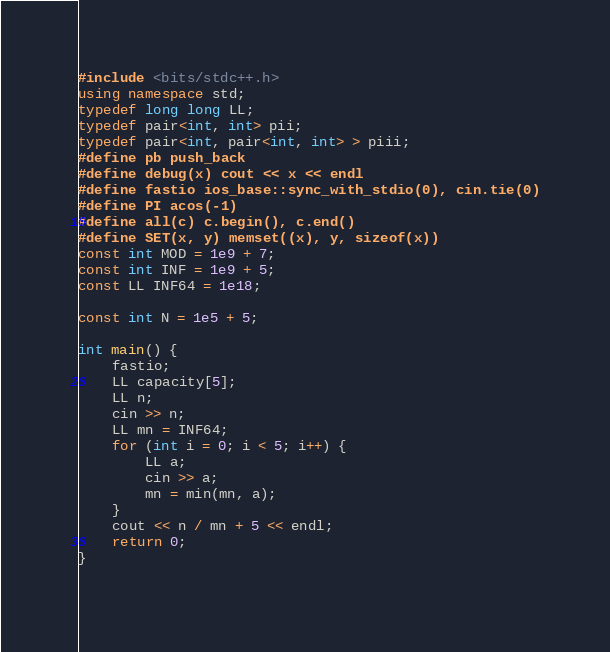<code> <loc_0><loc_0><loc_500><loc_500><_C++_>#include <bits/stdc++.h>
using namespace std;
typedef long long LL;
typedef pair<int, int> pii;
typedef pair<int, pair<int, int> > piii;
#define pb push_back
#define debug(x) cout << x << endl
#define fastio ios_base::sync_with_stdio(0), cin.tie(0)
#define PI acos(-1)
#define all(c) c.begin(), c.end()
#define SET(x, y) memset((x), y, sizeof(x))
const int MOD = 1e9 + 7;
const int INF = 1e9 + 5;
const LL INF64 = 1e18;

const int N = 1e5 + 5;

int main() {
	fastio;
	LL capacity[5];
	LL n;
	cin >> n;
	LL mn = INF64;
	for (int i = 0; i < 5; i++) {
		LL a;
		cin >> a;
		mn = min(mn, a);
	}
	cout << n / mn + 5 << endl;
	return 0;
}
		</code> 